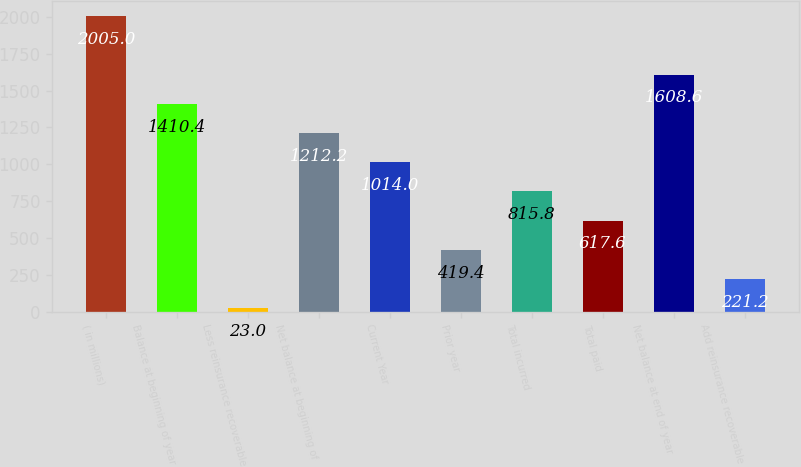Convert chart. <chart><loc_0><loc_0><loc_500><loc_500><bar_chart><fcel>( in millions)<fcel>Balance at beginning of year<fcel>Less reinsurance recoverable<fcel>Net balance at beginning of<fcel>Current Year<fcel>Prior year<fcel>Total incurred<fcel>Total paid<fcel>Net balance at end of year<fcel>Add reinsurance recoverable<nl><fcel>2005<fcel>1410.4<fcel>23<fcel>1212.2<fcel>1014<fcel>419.4<fcel>815.8<fcel>617.6<fcel>1608.6<fcel>221.2<nl></chart> 